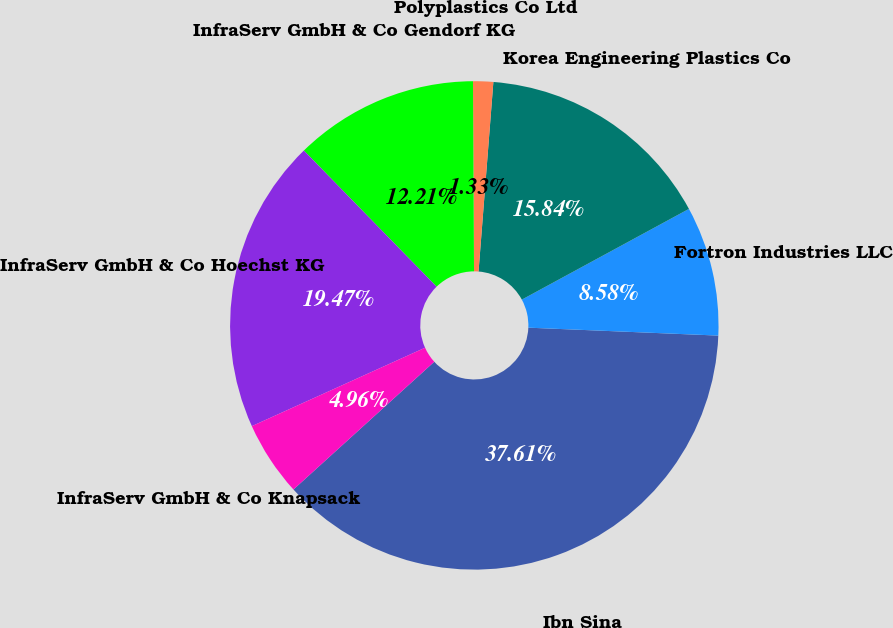<chart> <loc_0><loc_0><loc_500><loc_500><pie_chart><fcel>Ibn Sina<fcel>Fortron Industries LLC<fcel>Korea Engineering Plastics Co<fcel>Polyplastics Co Ltd<fcel>InfraServ GmbH & Co Gendorf KG<fcel>InfraServ GmbH & Co Hoechst KG<fcel>InfraServ GmbH & Co Knapsack<nl><fcel>37.61%<fcel>8.58%<fcel>15.84%<fcel>1.33%<fcel>12.21%<fcel>19.47%<fcel>4.96%<nl></chart> 